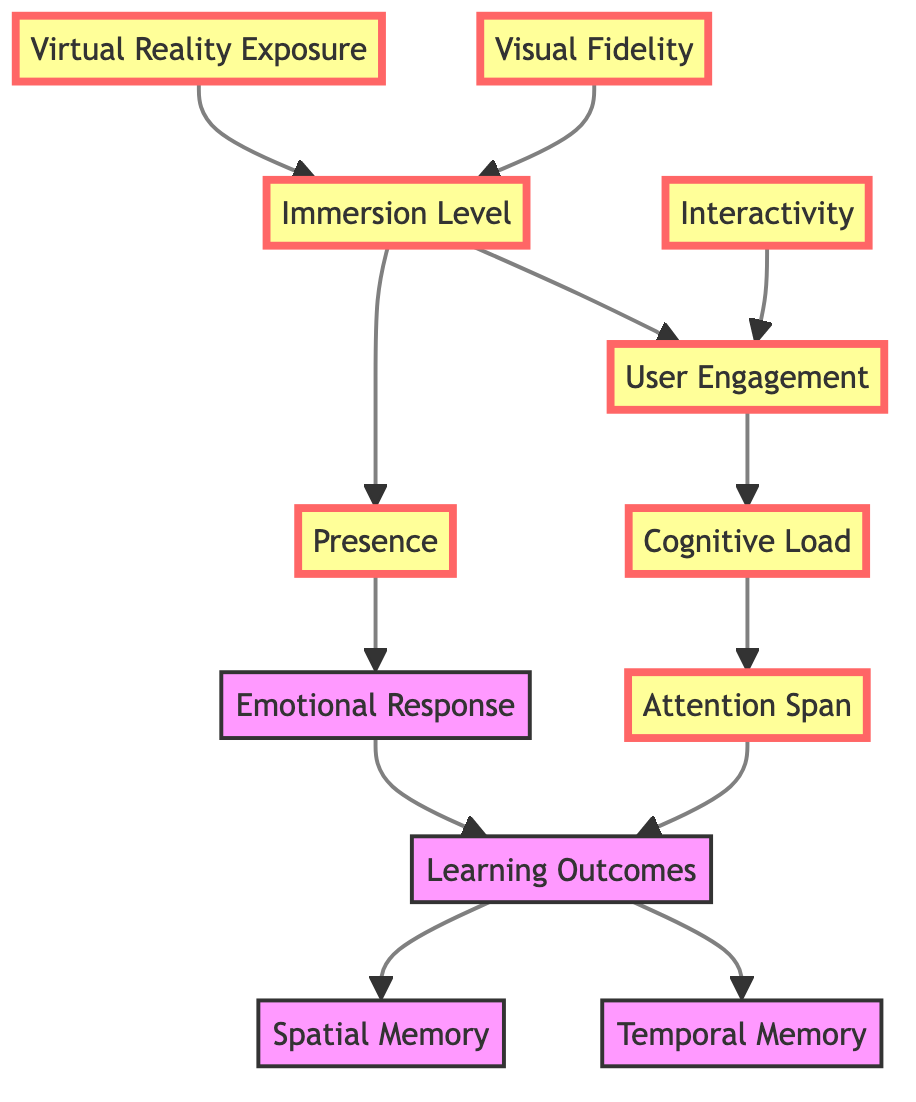What is the total number of variables in the diagram? The diagram lists 11 different variables that influence memory and attention in virtual reality.
Answer: 11 What variable does "Virtual Reality Exposure" directly influence? "Virtual Reality Exposure" has an arrow pointing to "Immersion Level," indicating a direct influence.
Answer: Immersion Level Which two variables are directly linked to "Immersion Level"? "Immersion Level" has direct pathways indicated by arrows leading to "User Engagement" and "Presence."
Answer: User Engagement, Presence What variable does "Cognitive Load" directly affect? There is a direct arrow from "Cognitive Load" to "Attention Span" in the diagram, showing it affects this variable.
Answer: Attention Span How many edges are present in the diagram? By counting the arrows that connect the various nodes, there are a total of 11 directed edges in the graph.
Answer: 11 Which variable has "Emotional Response" leading into it? The diagram shows an arrow flowing from "Emotional Response" to "Learning Outcomes," indicating a direct influence.
Answer: Learning Outcomes What is the relationship between "Attention Span" and "Learning Outcomes"? The diagram highlights a direct pathway from "Attention Span" to "Learning Outcomes," signifying that as attention span increases, learning outcomes are affected.
Answer: Direct influence Which variable influences both "Spatial Memory" and "Temporal Memory"? "Learning Outcomes" is shown to have direct arrows leading to both "Spatial Memory" and "Temporal Memory" in the graph.
Answer: Learning Outcomes Which two factors have the most pathways leading into them? By analyzing the directed arrows, "Immersion Level" and "Learning Outcomes" both have multiple incoming paths from different variables.
Answer: Immersion Level, Learning Outcomes 